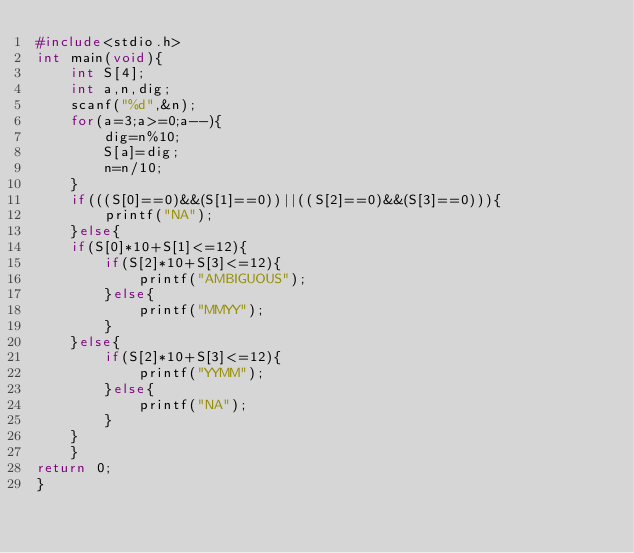Convert code to text. <code><loc_0><loc_0><loc_500><loc_500><_C_>#include<stdio.h>
int main(void){
	int S[4];
	int a,n,dig;
	scanf("%d",&n);
	for(a=3;a>=0;a--){
		dig=n%10;
		S[a]=dig;
		n=n/10;
	}
	if(((S[0]==0)&&(S[1]==0))||((S[2]==0)&&(S[3]==0))){
		printf("NA");
	}else{
	if(S[0]*10+S[1]<=12){
		if(S[2]*10+S[3]<=12){
			printf("AMBIGUOUS");
		}else{
			printf("MMYY");
		}
	}else{
		if(S[2]*10+S[3]<=12){
			printf("YYMM");
		}else{
			printf("NA");
		}
	}
	}
return 0;
}</code> 